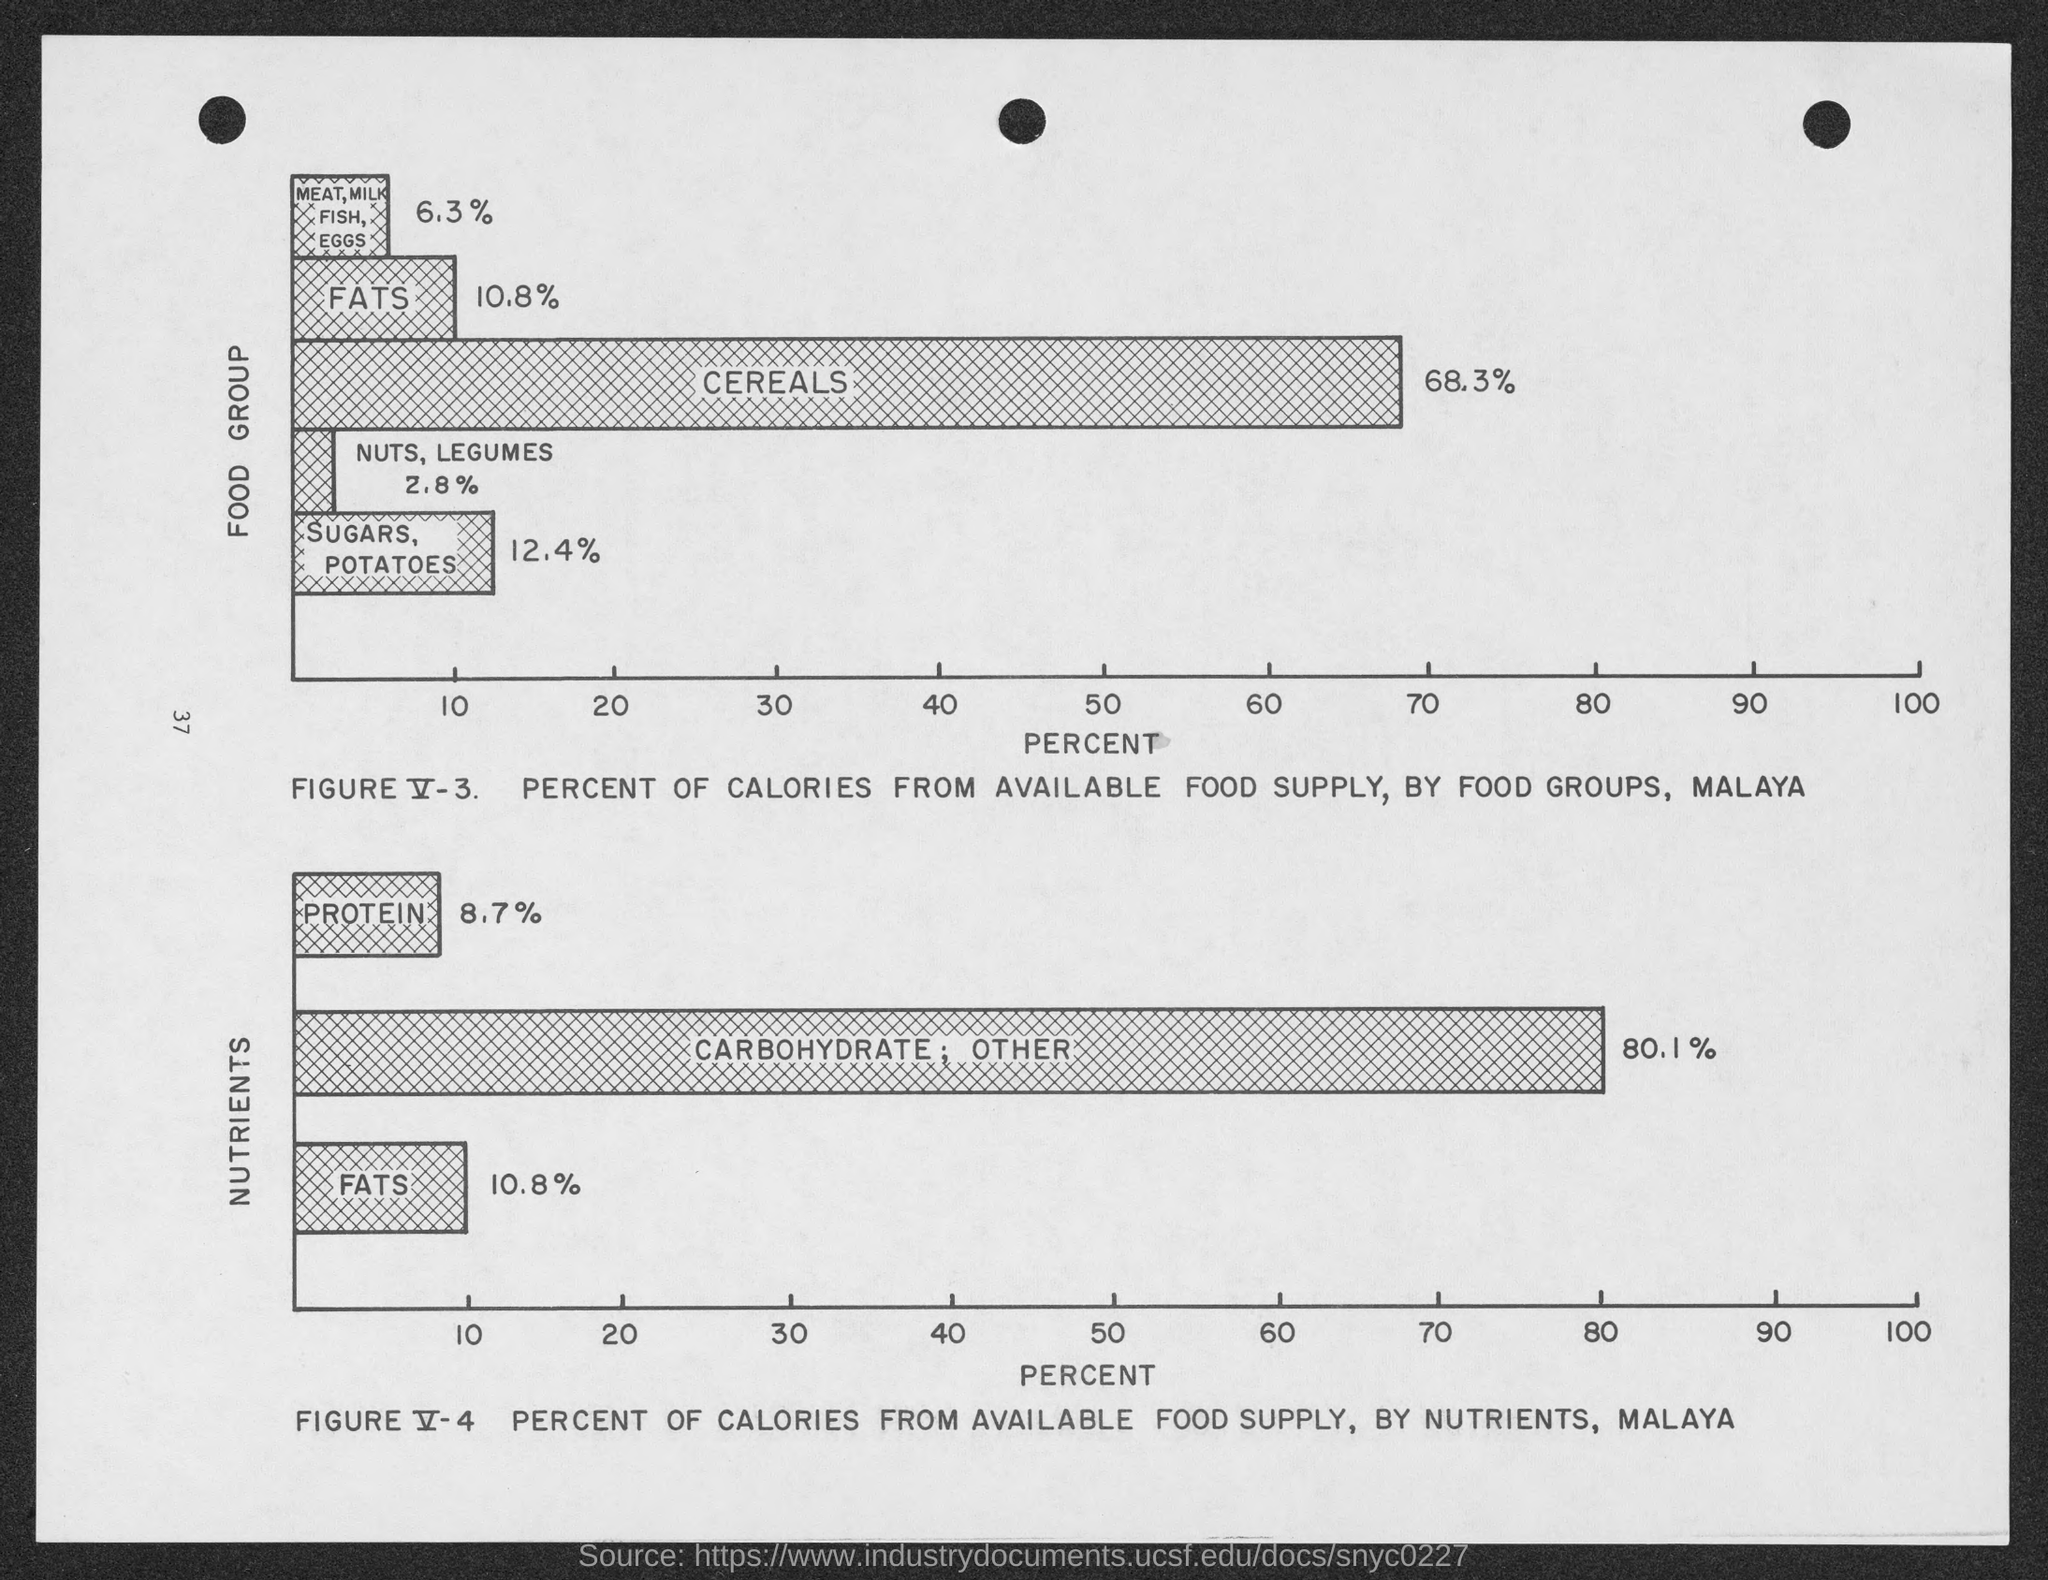Draw attention to some important aspects in this diagram. The number to the left-center of the page is 37. Nuts and legumes make up approximately 2.8% of the food group. According to the food group, meat, milk, fish, and eggs make up approximately 6.3% of the overall content. The nutrient contains 10.8% fats. Food group contains 10.8% fats. 